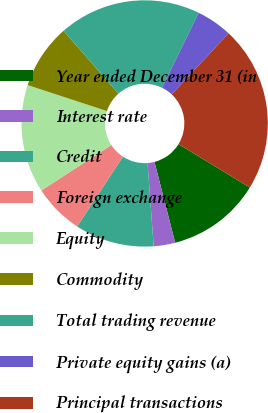Convert chart to OTSL. <chart><loc_0><loc_0><loc_500><loc_500><pie_chart><fcel>Year ended December 31 (in<fcel>Interest rate<fcel>Credit<fcel>Foreign exchange<fcel>Equity<fcel>Commodity<fcel>Total trading revenue<fcel>Private equity gains (a)<fcel>Principal transactions<nl><fcel>12.3%<fcel>2.82%<fcel>10.4%<fcel>6.61%<fcel>14.2%<fcel>8.51%<fcel>18.67%<fcel>4.71%<fcel>21.78%<nl></chart> 